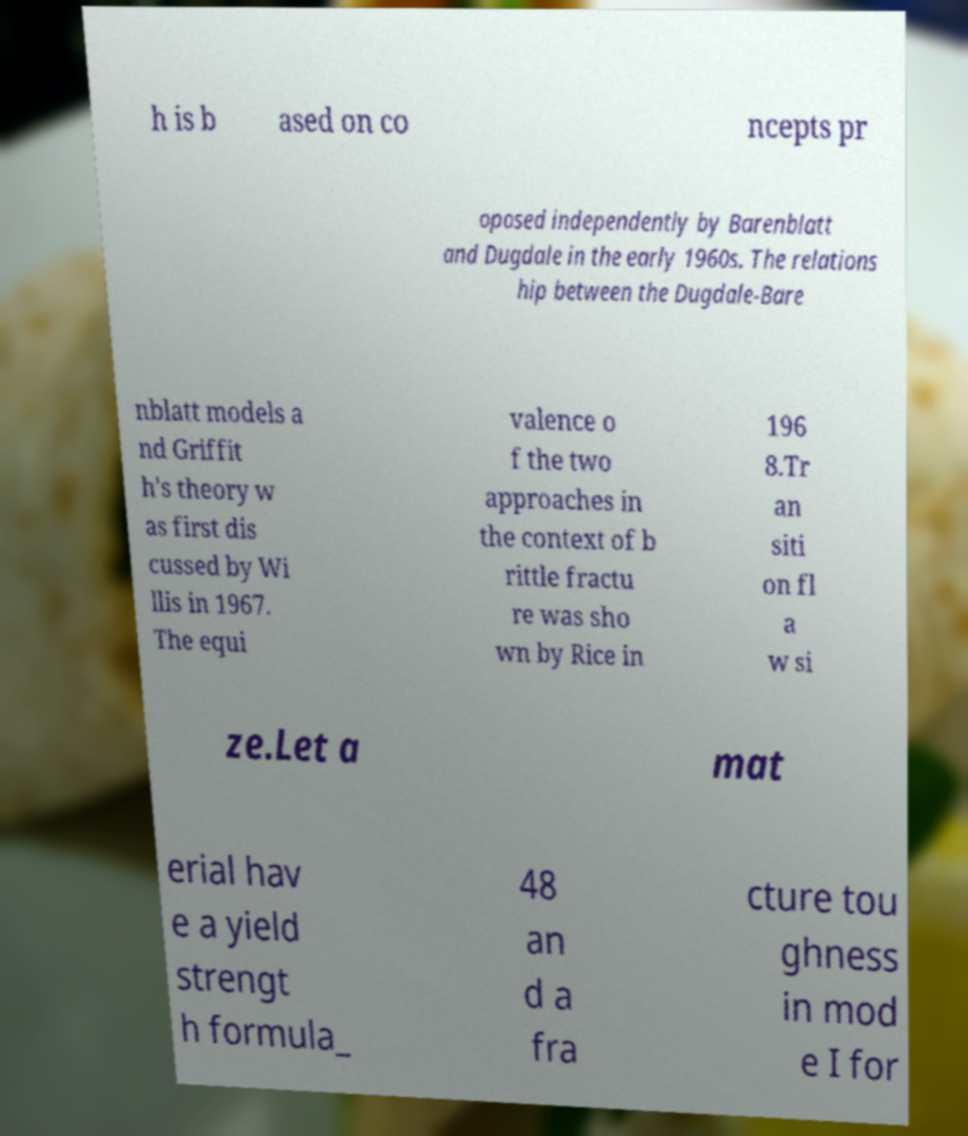Can you read and provide the text displayed in the image?This photo seems to have some interesting text. Can you extract and type it out for me? h is b ased on co ncepts pr oposed independently by Barenblatt and Dugdale in the early 1960s. The relations hip between the Dugdale-Bare nblatt models a nd Griffit h's theory w as first dis cussed by Wi llis in 1967. The equi valence o f the two approaches in the context of b rittle fractu re was sho wn by Rice in 196 8.Tr an siti on fl a w si ze.Let a mat erial hav e a yield strengt h formula_ 48 an d a fra cture tou ghness in mod e I for 